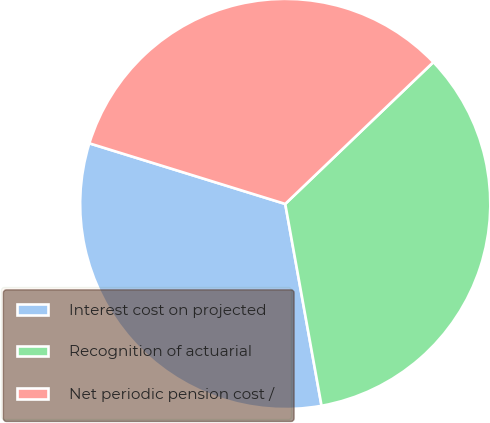Convert chart to OTSL. <chart><loc_0><loc_0><loc_500><loc_500><pie_chart><fcel>Interest cost on projected<fcel>Recognition of actuarial<fcel>Net periodic pension cost /<nl><fcel>32.61%<fcel>34.32%<fcel>33.07%<nl></chart> 